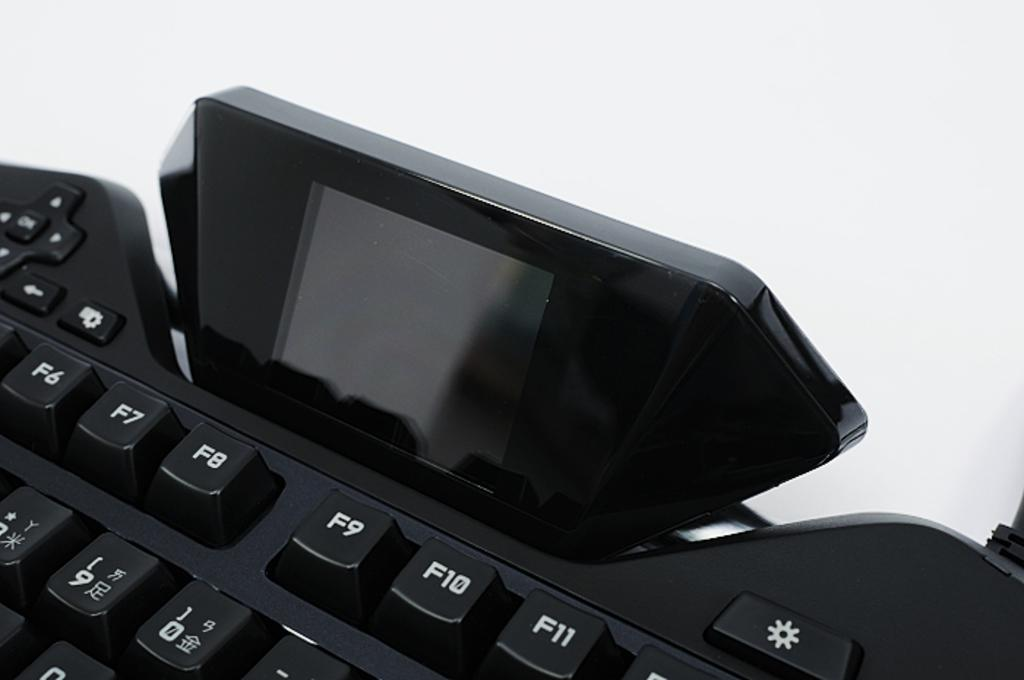Provide a one-sentence caption for the provided image. a keyboard with the F row visible and japanese characters below it. 